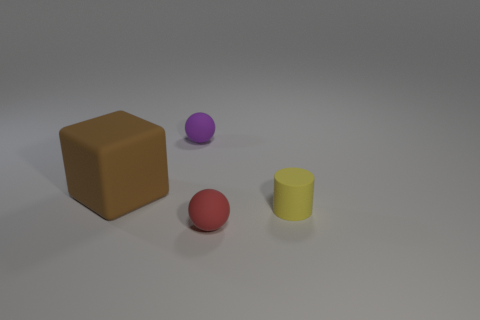What shape is the tiny matte object that is to the right of the tiny ball on the right side of the ball that is left of the small red object? The tiny matte object situated to the right of the tiny ball, which itself is on the right side of the ball left of the small red object, is a cylinder. Its shape is characterized by its circular base and straight, parallel sides. 